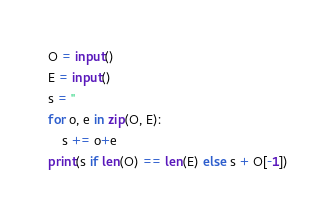<code> <loc_0><loc_0><loc_500><loc_500><_Python_>O = input()
E = input()
s = ''
for o, e in zip(O, E):
    s += o+e
print(s if len(O) == len(E) else s + O[-1])</code> 